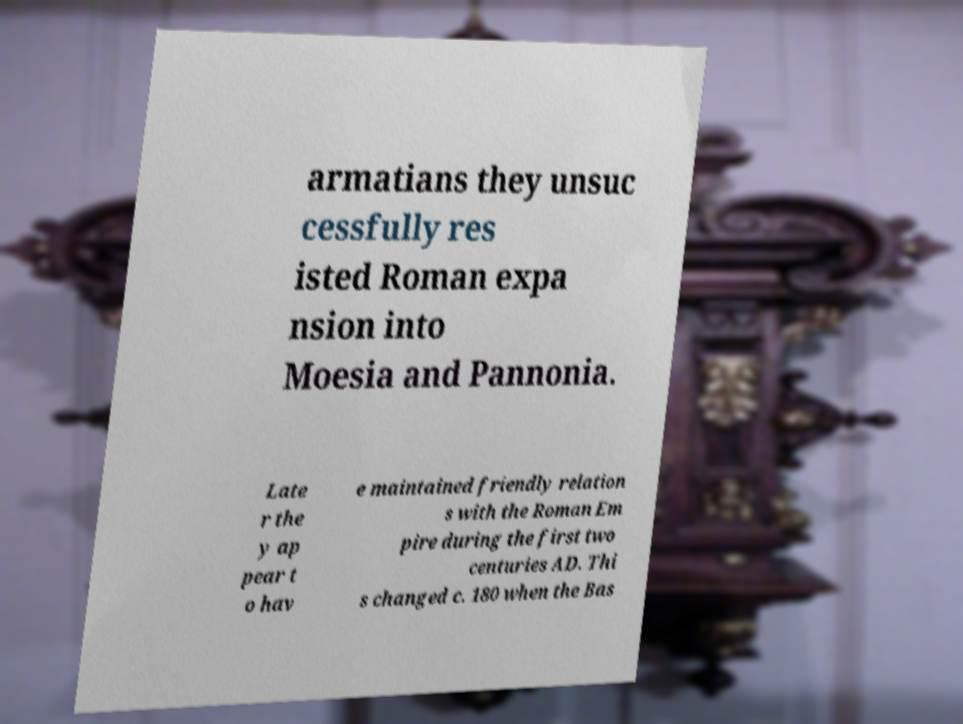Can you read and provide the text displayed in the image?This photo seems to have some interesting text. Can you extract and type it out for me? armatians they unsuc cessfully res isted Roman expa nsion into Moesia and Pannonia. Late r the y ap pear t o hav e maintained friendly relation s with the Roman Em pire during the first two centuries AD. Thi s changed c. 180 when the Bas 